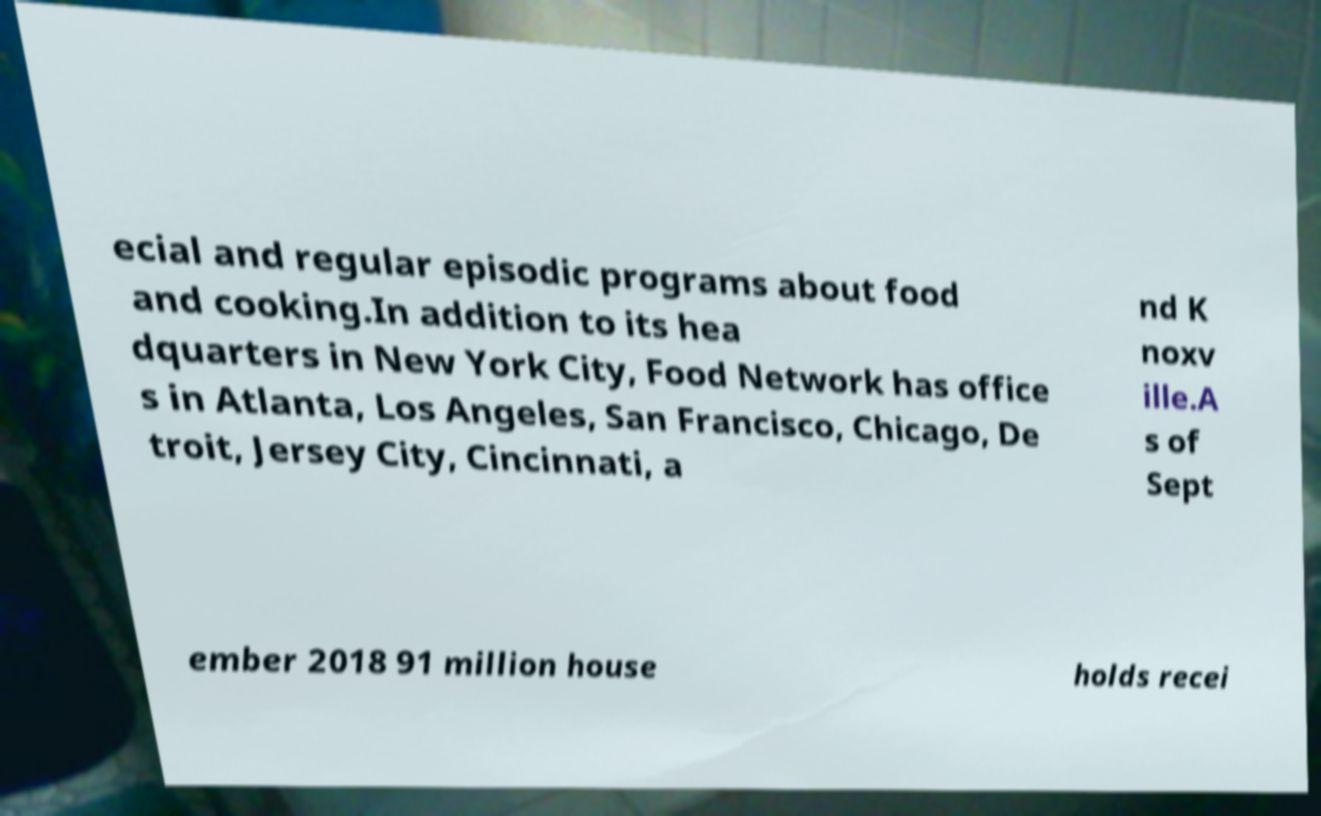Could you extract and type out the text from this image? ecial and regular episodic programs about food and cooking.In addition to its hea dquarters in New York City, Food Network has office s in Atlanta, Los Angeles, San Francisco, Chicago, De troit, Jersey City, Cincinnati, a nd K noxv ille.A s of Sept ember 2018 91 million house holds recei 